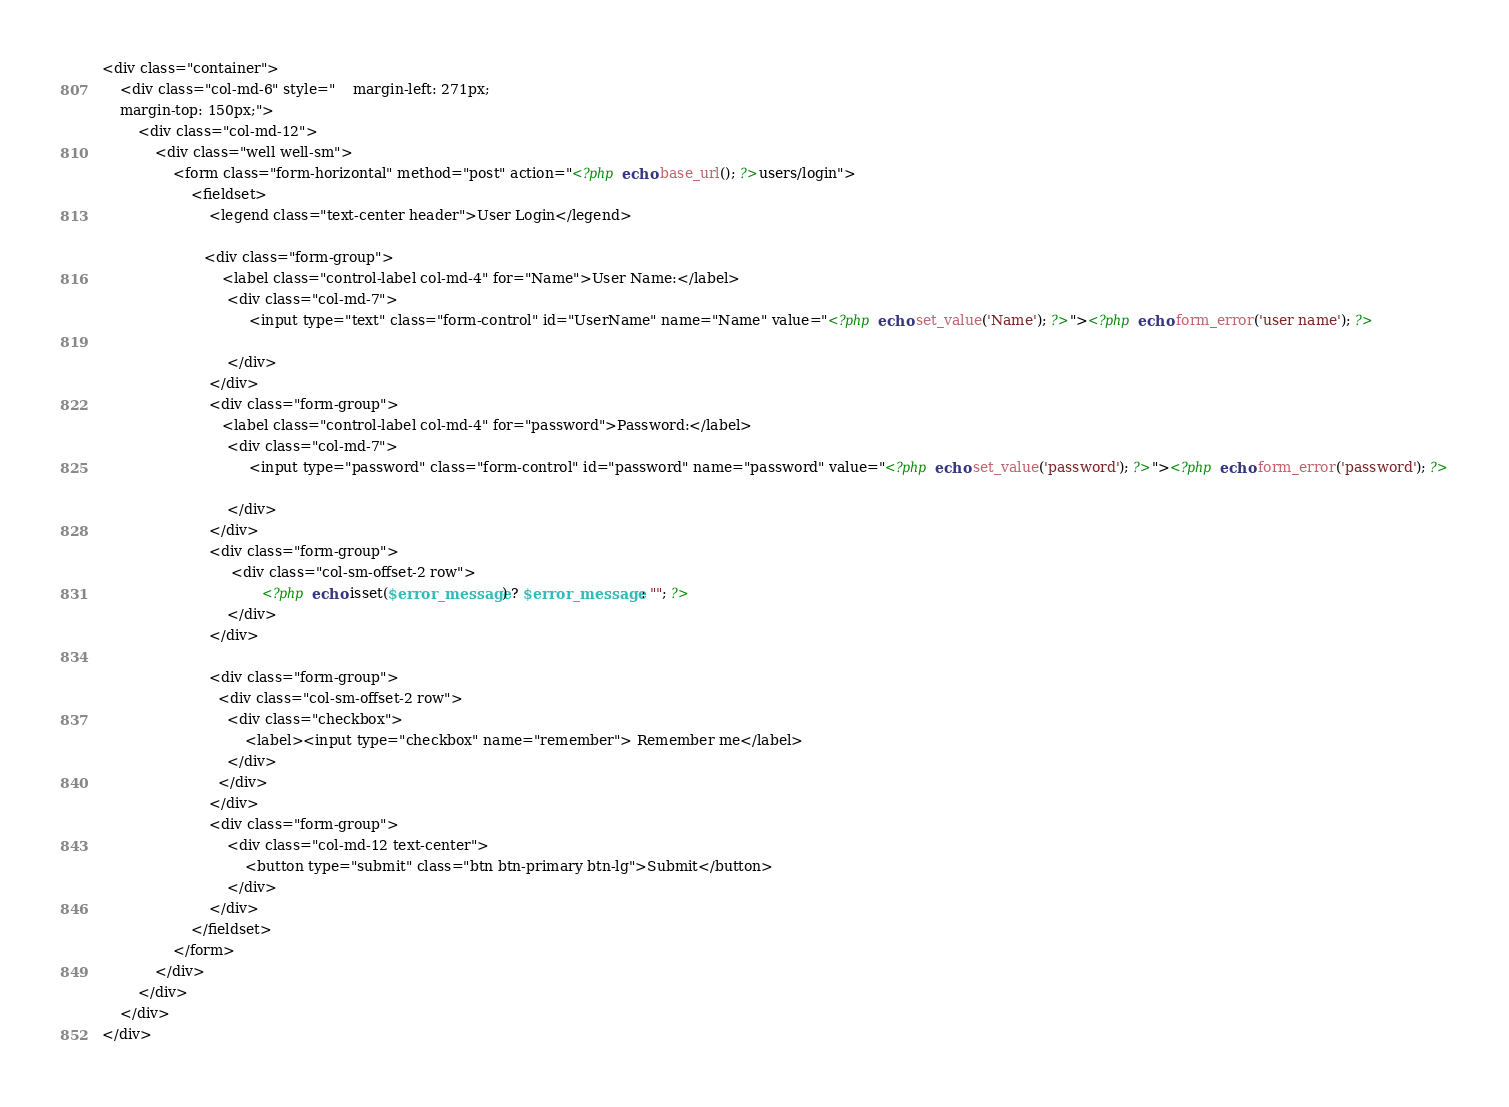Convert code to text. <code><loc_0><loc_0><loc_500><loc_500><_PHP_>
<div class="container">
    <div class="col-md-6" style="    margin-left: 271px;
    margin-top: 150px;">
        <div class="col-md-12">
            <div class="well well-sm">
                <form class="form-horizontal" method="post" action="<?php echo base_url(); ?>users/login"> 
                    <fieldset>
                        <legend class="text-center header">User Login</legend>

                       <div class="form-group">
                           <label class="control-label col-md-4" for="Name">User Name:</label>
                            <div class="col-md-7">
                                 <input type="text" class="form-control" id="UserName" name="Name" value="<?php echo set_value('Name'); ?>"><?php echo form_error('user name'); ?>
                            
                            </div>
                        </div>
                        <div class="form-group">
                           <label class="control-label col-md-4" for="password">Password:</label>
                            <div class="col-md-7">
                                 <input type="password" class="form-control" id="password" name="password" value="<?php echo set_value('password'); ?>"><?php echo form_error('password'); ?>
                            
                            </div>
                        </div>
                        <div class="form-group">  
                             <div class="col-sm-offset-2 row">
                                    <?php echo isset($error_message) ? $error_message : ""; ?>
                            </div> 
                        </div>
                       
                        <div class="form-group">        
                          <div class="col-sm-offset-2 row">
                            <div class="checkbox">
                                <label><input type="checkbox" name="remember"> Remember me</label>
                            </div>
                          </div>
                        </div>
                        <div class="form-group">
                            <div class="col-md-12 text-center">
                                <button type="submit" class="btn btn-primary btn-lg">Submit</button>
                            </div>
                        </div>
                    </fieldset>
                </form>
            </div>
        </div>
    </div>
</div></code> 